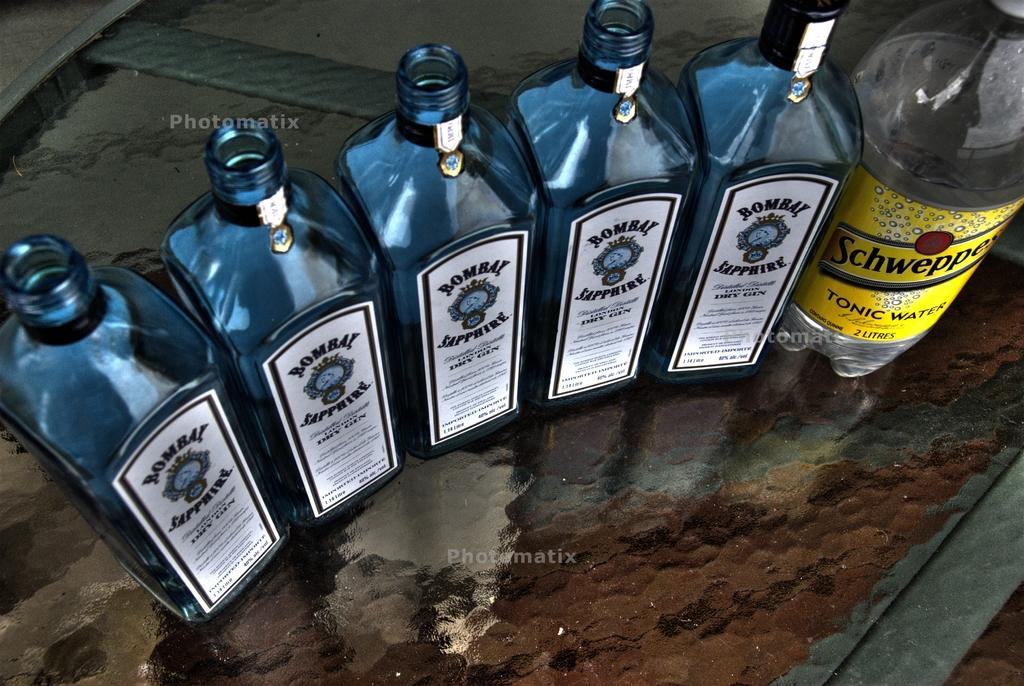What objects are present in the image? There are bottles in the image. Where are the bottles located? The bottles are on a table. How many kittens are sitting in the stew in the image? There are no kittens or stew present in the image; it only features bottles on a table. 